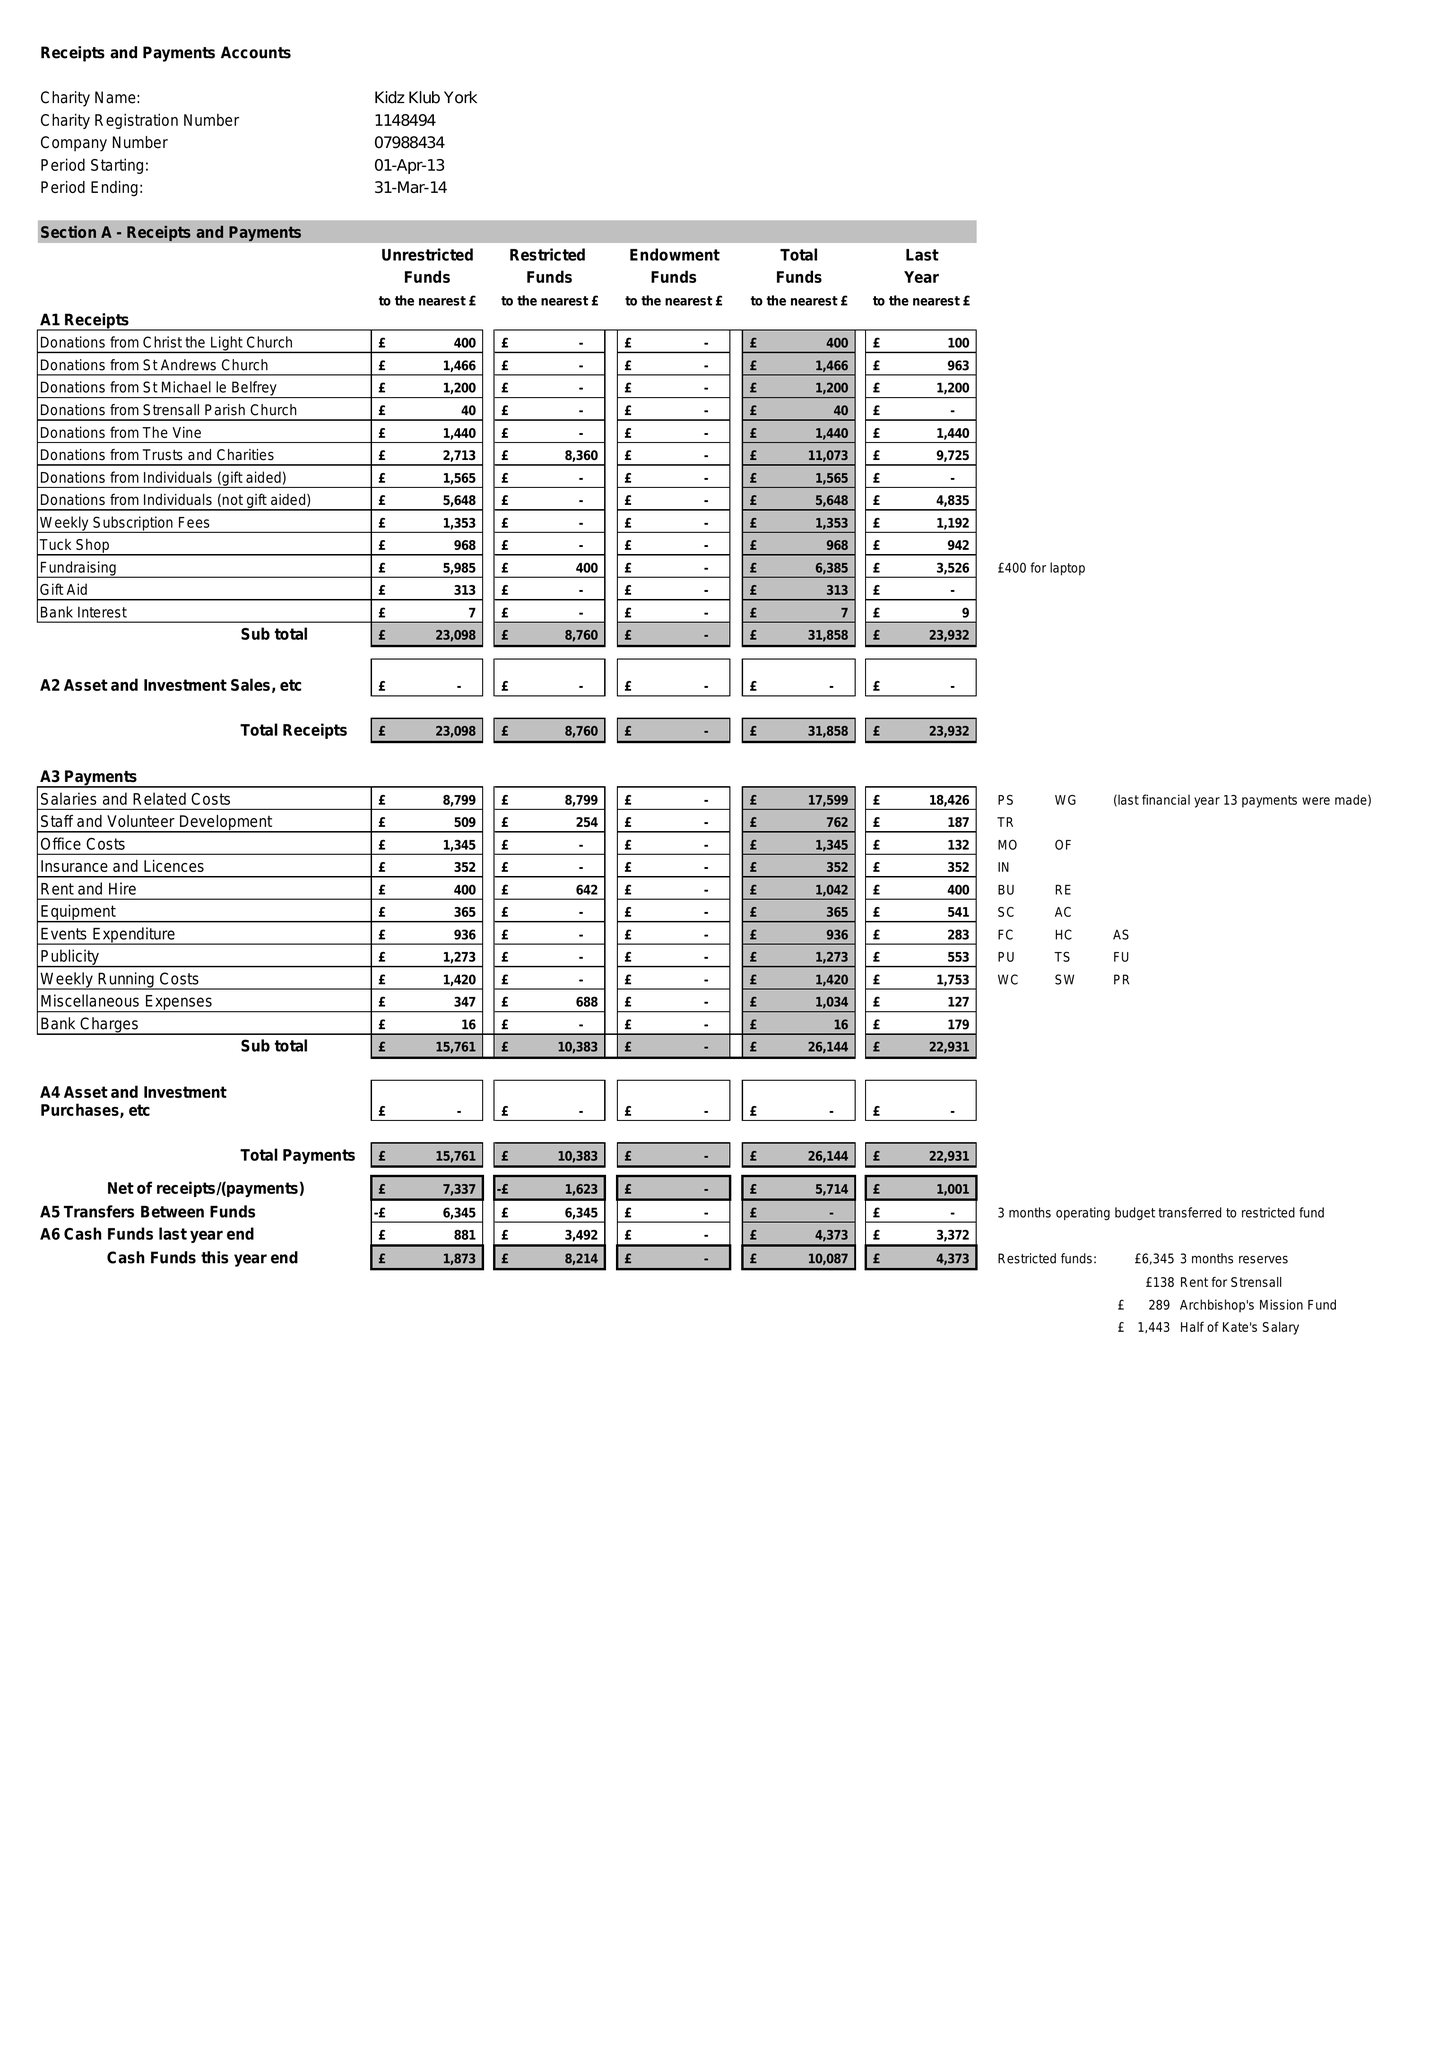What is the value for the report_date?
Answer the question using a single word or phrase. 2014-03-31 